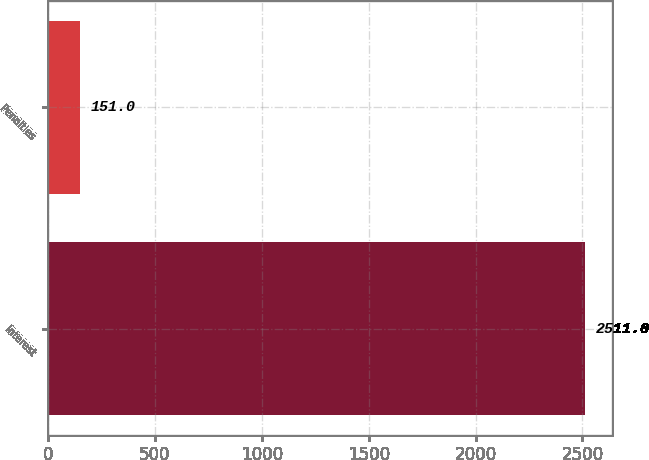Convert chart to OTSL. <chart><loc_0><loc_0><loc_500><loc_500><bar_chart><fcel>Interest<fcel>Penalties<nl><fcel>2511<fcel>151<nl></chart> 